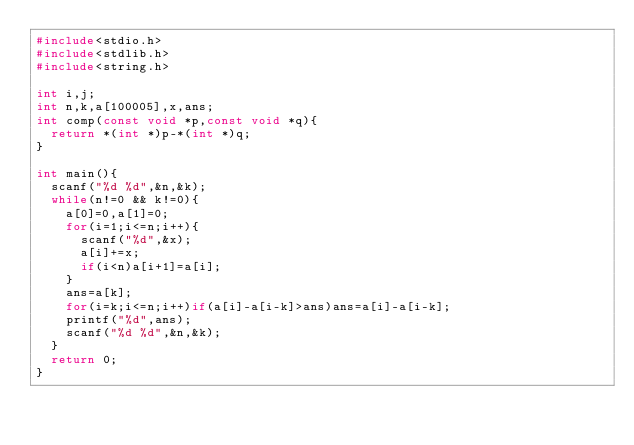Convert code to text. <code><loc_0><loc_0><loc_500><loc_500><_C_>#include<stdio.h>
#include<stdlib.h>
#include<string.h>

int i,j;
int n,k,a[100005],x,ans;
int comp(const void *p,const void *q){
	return *(int *)p-*(int *)q;
}

int main(){
	scanf("%d %d",&n,&k);
	while(n!=0 && k!=0){
		a[0]=0,a[1]=0;
		for(i=1;i<=n;i++){
			scanf("%d",&x);
			a[i]+=x;
			if(i<n)a[i+1]=a[i];
		}
		ans=a[k];
		for(i=k;i<=n;i++)if(a[i]-a[i-k]>ans)ans=a[i]-a[i-k];
		printf("%d",ans);
		scanf("%d %d",&n,&k);
	}
	return 0;
}</code> 